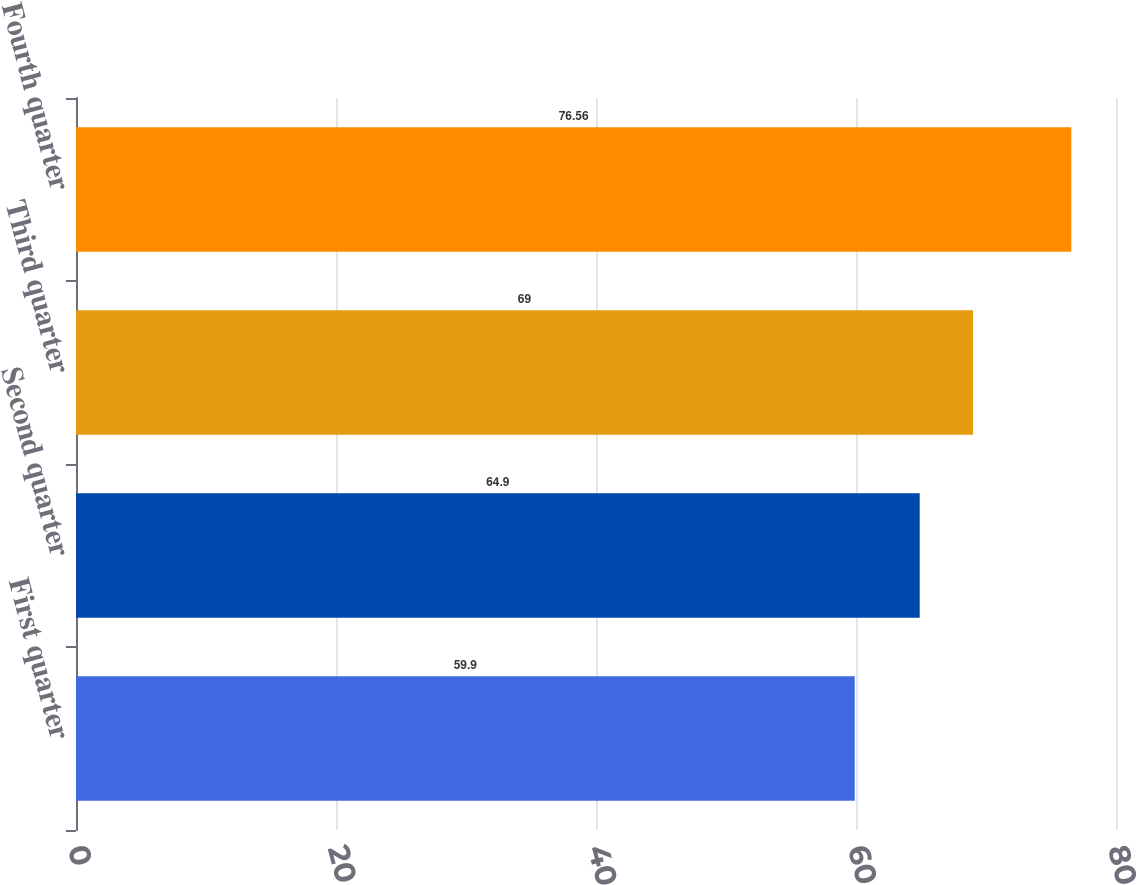Convert chart. <chart><loc_0><loc_0><loc_500><loc_500><bar_chart><fcel>First quarter<fcel>Second quarter<fcel>Third quarter<fcel>Fourth quarter<nl><fcel>59.9<fcel>64.9<fcel>69<fcel>76.56<nl></chart> 